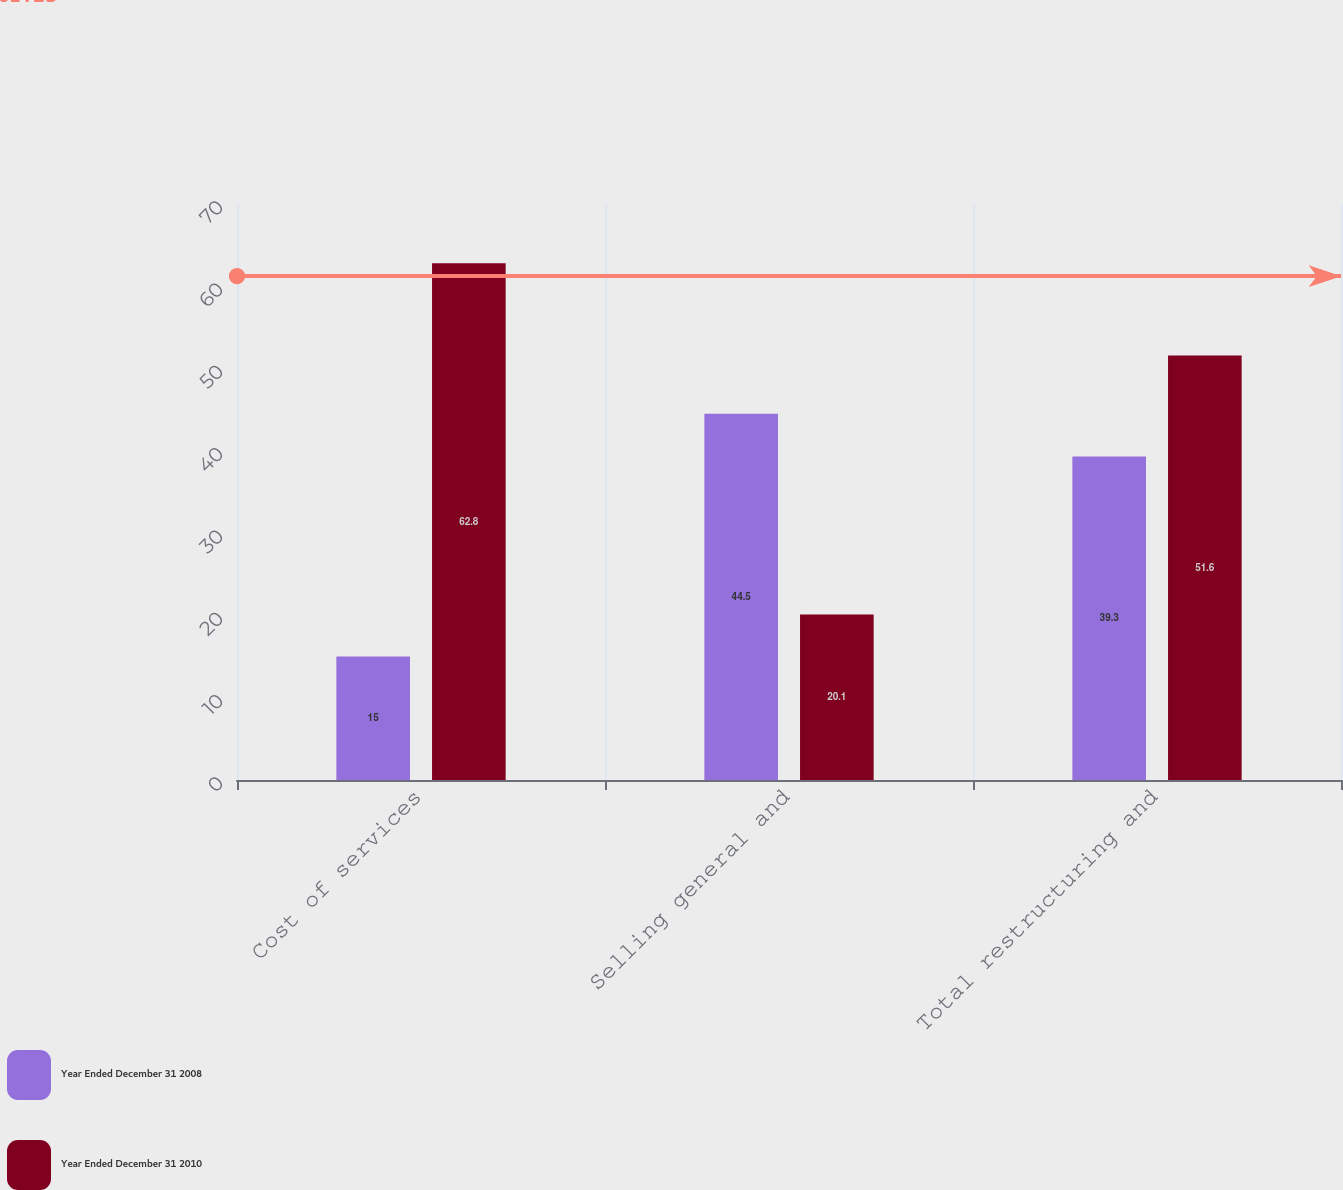Convert chart. <chart><loc_0><loc_0><loc_500><loc_500><stacked_bar_chart><ecel><fcel>Cost of services<fcel>Selling general and<fcel>Total restructuring and<nl><fcel>Year Ended December 31 2008<fcel>15<fcel>44.5<fcel>39.3<nl><fcel>Year Ended December 31 2010<fcel>62.8<fcel>20.1<fcel>51.6<nl></chart> 